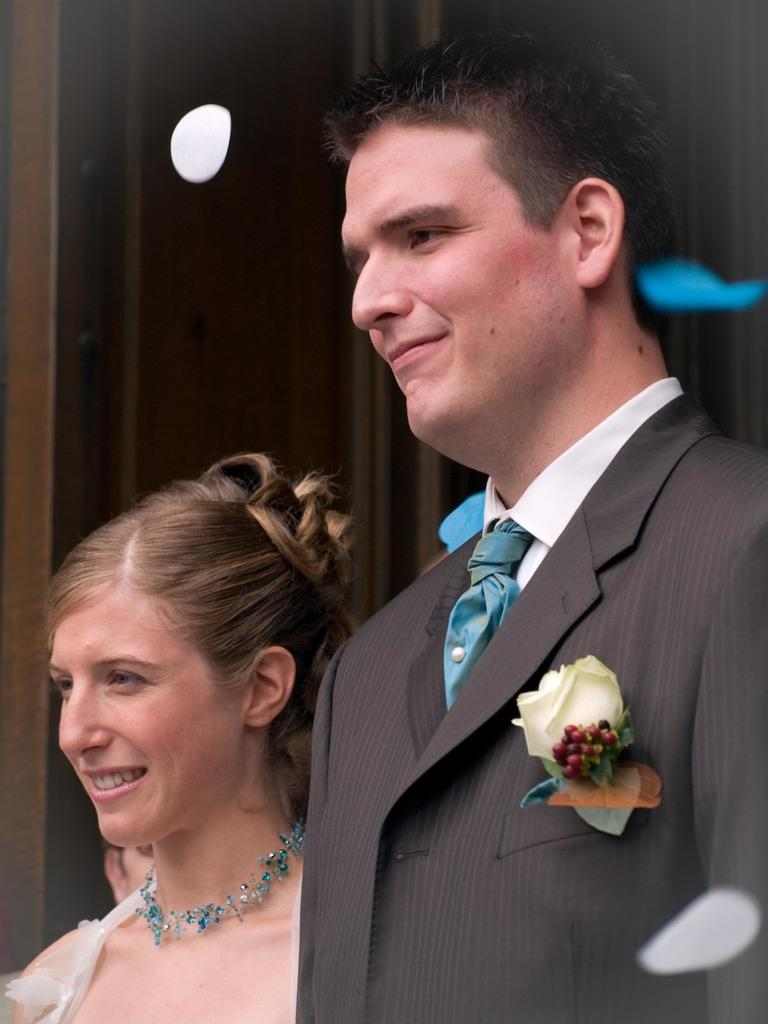How many people are present in the image? There are two people, a man and a woman, present in the image. What are the man and woman doing in the image? The man and woman are standing. What can be seen in the background of the image? There is a wall in the background of the image. What type of library can be seen in the background of the image? There is no library present in the image; it only features a man, a woman, and a wall in the background. 